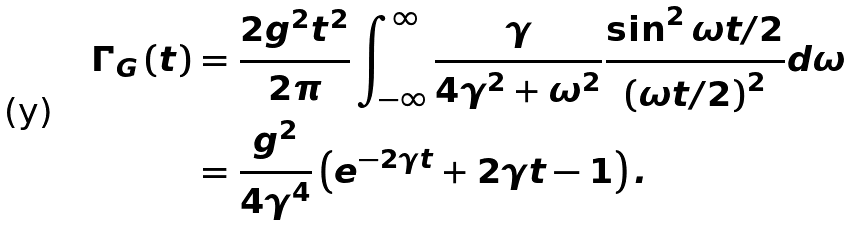Convert formula to latex. <formula><loc_0><loc_0><loc_500><loc_500>\Gamma _ { G } \left ( t \right ) & = \frac { 2 g ^ { 2 } t ^ { 2 } } { 2 \pi } \int _ { - \infty } ^ { \infty } \frac { \gamma } { 4 \gamma ^ { 2 } + \omega ^ { 2 } } \frac { \sin ^ { 2 } \omega t / 2 } { \left ( \omega t / 2 \right ) ^ { 2 } } d \omega \\ & = \frac { g ^ { 2 } } { 4 \gamma ^ { 4 } } \left ( e ^ { - 2 \gamma t } + 2 \gamma t - 1 \right ) .</formula> 